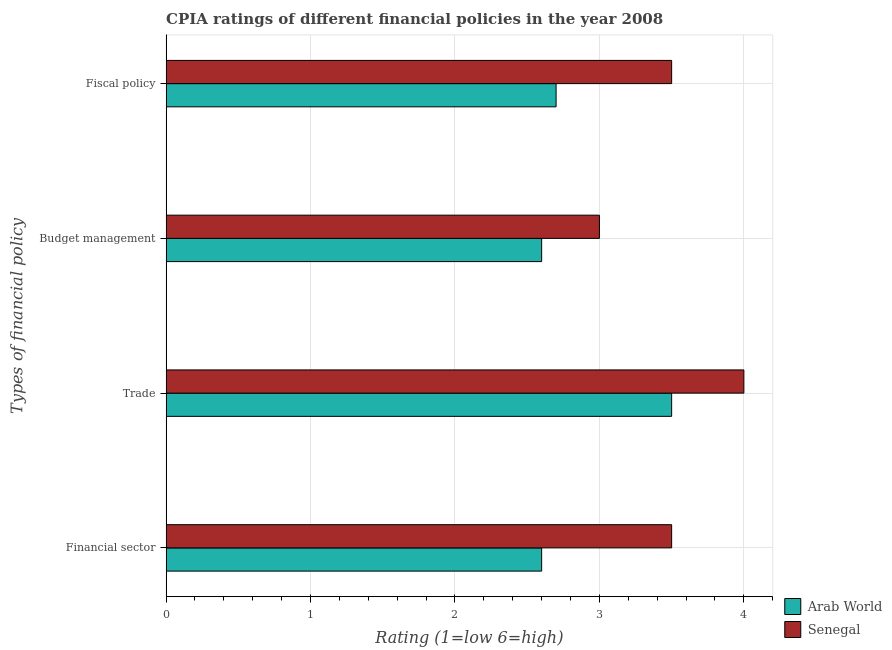How many different coloured bars are there?
Make the answer very short. 2. How many bars are there on the 3rd tick from the bottom?
Offer a very short reply. 2. What is the label of the 4th group of bars from the top?
Offer a very short reply. Financial sector. What is the cpia rating of trade in Arab World?
Make the answer very short. 3.5. In which country was the cpia rating of budget management maximum?
Your answer should be very brief. Senegal. In which country was the cpia rating of fiscal policy minimum?
Your answer should be very brief. Arab World. What is the difference between the cpia rating of financial sector in Arab World and that in Senegal?
Ensure brevity in your answer.  -0.9. What is the difference between the cpia rating of trade in Arab World and the cpia rating of fiscal policy in Senegal?
Your answer should be very brief. 0. What is the difference between the cpia rating of budget management and cpia rating of financial sector in Senegal?
Offer a terse response. -0.5. What is the ratio of the cpia rating of fiscal policy in Senegal to that in Arab World?
Give a very brief answer. 1.3. Is the difference between the cpia rating of trade in Senegal and Arab World greater than the difference between the cpia rating of fiscal policy in Senegal and Arab World?
Provide a short and direct response. No. What is the difference between the highest and the second highest cpia rating of trade?
Provide a succinct answer. 0.5. What is the difference between the highest and the lowest cpia rating of fiscal policy?
Your response must be concise. 0.8. Is it the case that in every country, the sum of the cpia rating of financial sector and cpia rating of trade is greater than the sum of cpia rating of budget management and cpia rating of fiscal policy?
Your response must be concise. No. What does the 2nd bar from the top in Budget management represents?
Make the answer very short. Arab World. What does the 1st bar from the bottom in Budget management represents?
Give a very brief answer. Arab World. Is it the case that in every country, the sum of the cpia rating of financial sector and cpia rating of trade is greater than the cpia rating of budget management?
Ensure brevity in your answer.  Yes. What is the difference between two consecutive major ticks on the X-axis?
Offer a very short reply. 1. Are the values on the major ticks of X-axis written in scientific E-notation?
Keep it short and to the point. No. Does the graph contain grids?
Provide a succinct answer. Yes. Where does the legend appear in the graph?
Your response must be concise. Bottom right. How are the legend labels stacked?
Your answer should be compact. Vertical. What is the title of the graph?
Provide a succinct answer. CPIA ratings of different financial policies in the year 2008. Does "Italy" appear as one of the legend labels in the graph?
Provide a succinct answer. No. What is the label or title of the X-axis?
Make the answer very short. Rating (1=low 6=high). What is the label or title of the Y-axis?
Ensure brevity in your answer.  Types of financial policy. What is the Rating (1=low 6=high) of Arab World in Trade?
Ensure brevity in your answer.  3.5. What is the Rating (1=low 6=high) of Arab World in Budget management?
Provide a succinct answer. 2.6. What is the Rating (1=low 6=high) of Senegal in Fiscal policy?
Give a very brief answer. 3.5. Across all Types of financial policy, what is the maximum Rating (1=low 6=high) in Arab World?
Provide a succinct answer. 3.5. Across all Types of financial policy, what is the maximum Rating (1=low 6=high) in Senegal?
Make the answer very short. 4. What is the total Rating (1=low 6=high) of Senegal in the graph?
Make the answer very short. 14. What is the difference between the Rating (1=low 6=high) of Arab World in Financial sector and that in Trade?
Ensure brevity in your answer.  -0.9. What is the difference between the Rating (1=low 6=high) of Senegal in Financial sector and that in Trade?
Provide a short and direct response. -0.5. What is the difference between the Rating (1=low 6=high) of Arab World in Financial sector and that in Budget management?
Keep it short and to the point. 0. What is the difference between the Rating (1=low 6=high) of Arab World in Financial sector and that in Fiscal policy?
Your answer should be very brief. -0.1. What is the difference between the Rating (1=low 6=high) of Senegal in Financial sector and that in Fiscal policy?
Provide a short and direct response. 0. What is the difference between the Rating (1=low 6=high) of Arab World in Trade and that in Fiscal policy?
Your answer should be very brief. 0.8. What is the difference between the Rating (1=low 6=high) in Arab World in Budget management and that in Fiscal policy?
Provide a short and direct response. -0.1. What is the difference between the Rating (1=low 6=high) of Senegal in Budget management and that in Fiscal policy?
Your answer should be compact. -0.5. What is the difference between the Rating (1=low 6=high) in Arab World in Financial sector and the Rating (1=low 6=high) in Senegal in Trade?
Provide a short and direct response. -1.4. What is the difference between the Rating (1=low 6=high) in Arab World in Financial sector and the Rating (1=low 6=high) in Senegal in Budget management?
Offer a terse response. -0.4. What is the difference between the Rating (1=low 6=high) of Arab World in Trade and the Rating (1=low 6=high) of Senegal in Budget management?
Provide a succinct answer. 0.5. What is the difference between the Rating (1=low 6=high) in Arab World in Trade and the Rating (1=low 6=high) in Senegal in Fiscal policy?
Offer a terse response. 0. What is the average Rating (1=low 6=high) of Arab World per Types of financial policy?
Ensure brevity in your answer.  2.85. What is the average Rating (1=low 6=high) in Senegal per Types of financial policy?
Offer a very short reply. 3.5. What is the difference between the Rating (1=low 6=high) in Arab World and Rating (1=low 6=high) in Senegal in Financial sector?
Your answer should be compact. -0.9. What is the ratio of the Rating (1=low 6=high) in Arab World in Financial sector to that in Trade?
Provide a succinct answer. 0.74. What is the ratio of the Rating (1=low 6=high) in Senegal in Financial sector to that in Trade?
Make the answer very short. 0.88. What is the ratio of the Rating (1=low 6=high) in Senegal in Financial sector to that in Budget management?
Give a very brief answer. 1.17. What is the ratio of the Rating (1=low 6=high) of Arab World in Financial sector to that in Fiscal policy?
Provide a succinct answer. 0.96. What is the ratio of the Rating (1=low 6=high) of Arab World in Trade to that in Budget management?
Ensure brevity in your answer.  1.35. What is the ratio of the Rating (1=low 6=high) in Senegal in Trade to that in Budget management?
Make the answer very short. 1.33. What is the ratio of the Rating (1=low 6=high) in Arab World in Trade to that in Fiscal policy?
Offer a terse response. 1.3. What is the ratio of the Rating (1=low 6=high) of Arab World in Budget management to that in Fiscal policy?
Your answer should be very brief. 0.96. What is the difference between the highest and the second highest Rating (1=low 6=high) of Arab World?
Your answer should be compact. 0.8. 